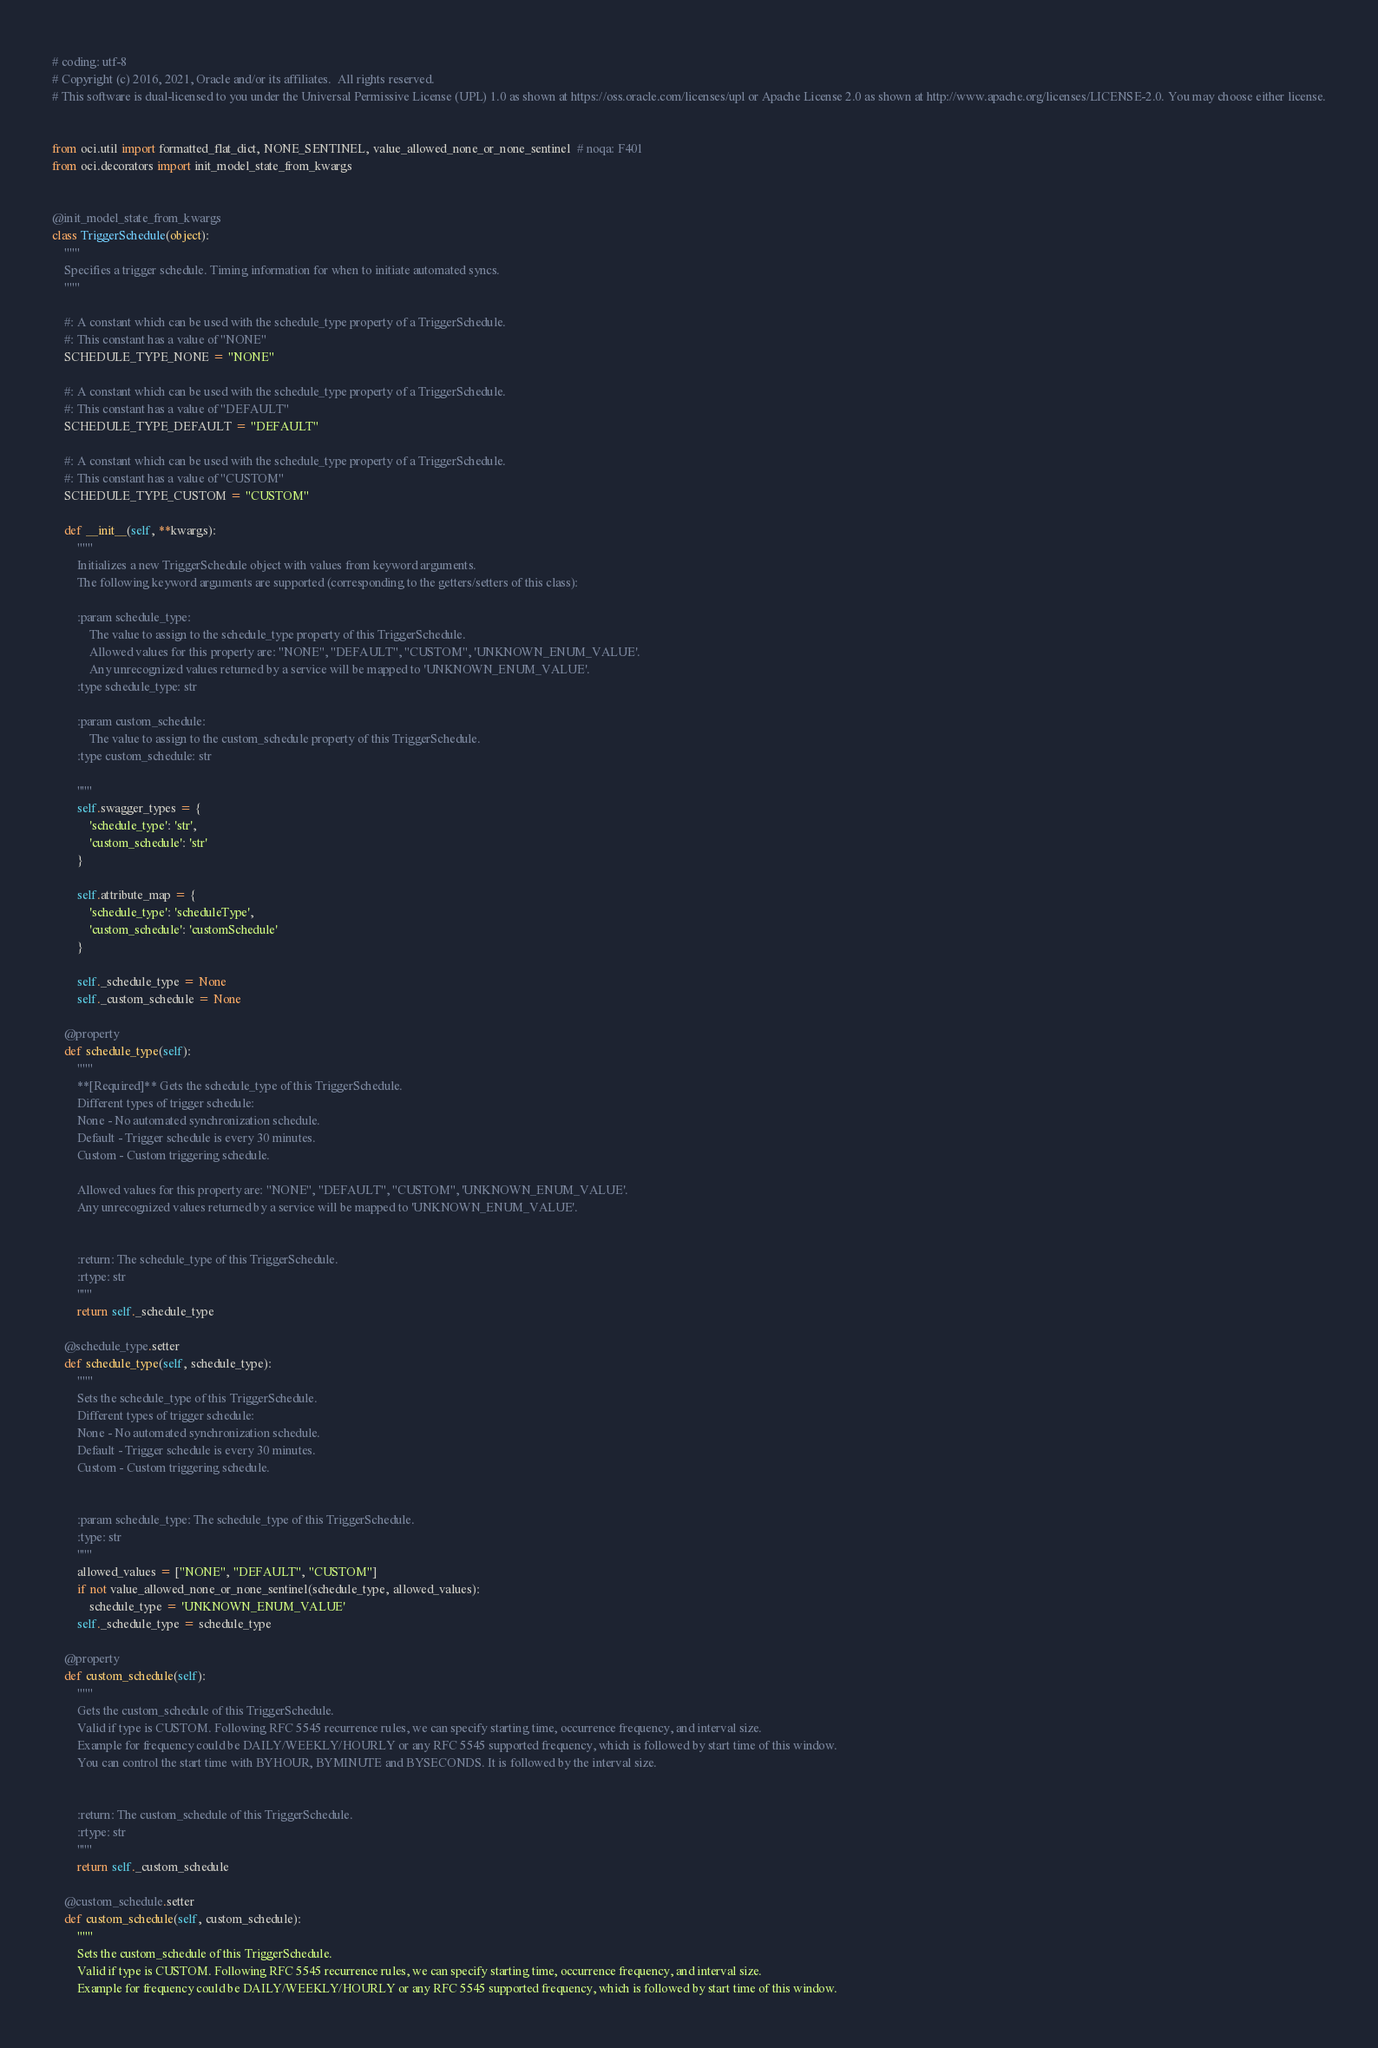Convert code to text. <code><loc_0><loc_0><loc_500><loc_500><_Python_># coding: utf-8
# Copyright (c) 2016, 2021, Oracle and/or its affiliates.  All rights reserved.
# This software is dual-licensed to you under the Universal Permissive License (UPL) 1.0 as shown at https://oss.oracle.com/licenses/upl or Apache License 2.0 as shown at http://www.apache.org/licenses/LICENSE-2.0. You may choose either license.


from oci.util import formatted_flat_dict, NONE_SENTINEL, value_allowed_none_or_none_sentinel  # noqa: F401
from oci.decorators import init_model_state_from_kwargs


@init_model_state_from_kwargs
class TriggerSchedule(object):
    """
    Specifies a trigger schedule. Timing information for when to initiate automated syncs.
    """

    #: A constant which can be used with the schedule_type property of a TriggerSchedule.
    #: This constant has a value of "NONE"
    SCHEDULE_TYPE_NONE = "NONE"

    #: A constant which can be used with the schedule_type property of a TriggerSchedule.
    #: This constant has a value of "DEFAULT"
    SCHEDULE_TYPE_DEFAULT = "DEFAULT"

    #: A constant which can be used with the schedule_type property of a TriggerSchedule.
    #: This constant has a value of "CUSTOM"
    SCHEDULE_TYPE_CUSTOM = "CUSTOM"

    def __init__(self, **kwargs):
        """
        Initializes a new TriggerSchedule object with values from keyword arguments.
        The following keyword arguments are supported (corresponding to the getters/setters of this class):

        :param schedule_type:
            The value to assign to the schedule_type property of this TriggerSchedule.
            Allowed values for this property are: "NONE", "DEFAULT", "CUSTOM", 'UNKNOWN_ENUM_VALUE'.
            Any unrecognized values returned by a service will be mapped to 'UNKNOWN_ENUM_VALUE'.
        :type schedule_type: str

        :param custom_schedule:
            The value to assign to the custom_schedule property of this TriggerSchedule.
        :type custom_schedule: str

        """
        self.swagger_types = {
            'schedule_type': 'str',
            'custom_schedule': 'str'
        }

        self.attribute_map = {
            'schedule_type': 'scheduleType',
            'custom_schedule': 'customSchedule'
        }

        self._schedule_type = None
        self._custom_schedule = None

    @property
    def schedule_type(self):
        """
        **[Required]** Gets the schedule_type of this TriggerSchedule.
        Different types of trigger schedule:
        None - No automated synchronization schedule.
        Default - Trigger schedule is every 30 minutes.
        Custom - Custom triggering schedule.

        Allowed values for this property are: "NONE", "DEFAULT", "CUSTOM", 'UNKNOWN_ENUM_VALUE'.
        Any unrecognized values returned by a service will be mapped to 'UNKNOWN_ENUM_VALUE'.


        :return: The schedule_type of this TriggerSchedule.
        :rtype: str
        """
        return self._schedule_type

    @schedule_type.setter
    def schedule_type(self, schedule_type):
        """
        Sets the schedule_type of this TriggerSchedule.
        Different types of trigger schedule:
        None - No automated synchronization schedule.
        Default - Trigger schedule is every 30 minutes.
        Custom - Custom triggering schedule.


        :param schedule_type: The schedule_type of this TriggerSchedule.
        :type: str
        """
        allowed_values = ["NONE", "DEFAULT", "CUSTOM"]
        if not value_allowed_none_or_none_sentinel(schedule_type, allowed_values):
            schedule_type = 'UNKNOWN_ENUM_VALUE'
        self._schedule_type = schedule_type

    @property
    def custom_schedule(self):
        """
        Gets the custom_schedule of this TriggerSchedule.
        Valid if type is CUSTOM. Following RFC 5545 recurrence rules, we can specify starting time, occurrence frequency, and interval size.
        Example for frequency could be DAILY/WEEKLY/HOURLY or any RFC 5545 supported frequency, which is followed by start time of this window.
        You can control the start time with BYHOUR, BYMINUTE and BYSECONDS. It is followed by the interval size.


        :return: The custom_schedule of this TriggerSchedule.
        :rtype: str
        """
        return self._custom_schedule

    @custom_schedule.setter
    def custom_schedule(self, custom_schedule):
        """
        Sets the custom_schedule of this TriggerSchedule.
        Valid if type is CUSTOM. Following RFC 5545 recurrence rules, we can specify starting time, occurrence frequency, and interval size.
        Example for frequency could be DAILY/WEEKLY/HOURLY or any RFC 5545 supported frequency, which is followed by start time of this window.</code> 